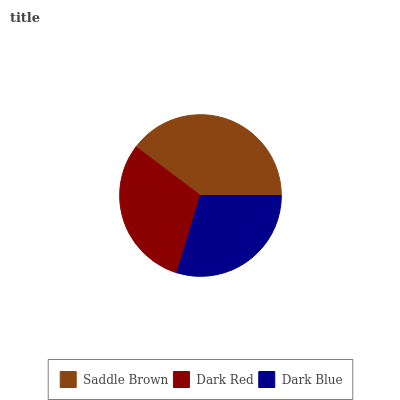Is Dark Blue the minimum?
Answer yes or no. Yes. Is Saddle Brown the maximum?
Answer yes or no. Yes. Is Dark Red the minimum?
Answer yes or no. No. Is Dark Red the maximum?
Answer yes or no. No. Is Saddle Brown greater than Dark Red?
Answer yes or no. Yes. Is Dark Red less than Saddle Brown?
Answer yes or no. Yes. Is Dark Red greater than Saddle Brown?
Answer yes or no. No. Is Saddle Brown less than Dark Red?
Answer yes or no. No. Is Dark Red the high median?
Answer yes or no. Yes. Is Dark Red the low median?
Answer yes or no. Yes. Is Saddle Brown the high median?
Answer yes or no. No. Is Dark Blue the low median?
Answer yes or no. No. 